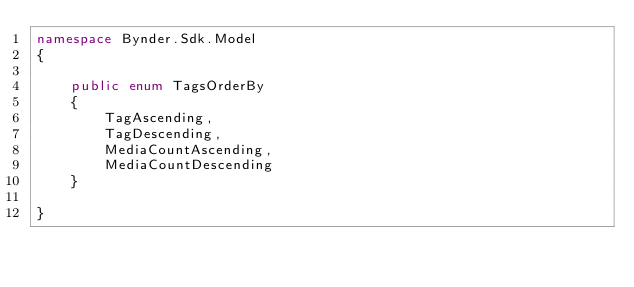Convert code to text. <code><loc_0><loc_0><loc_500><loc_500><_C#_>namespace Bynder.Sdk.Model
{

    public enum TagsOrderBy
    {
        TagAscending,
        TagDescending,
        MediaCountAscending,
        MediaCountDescending
    }

}
</code> 